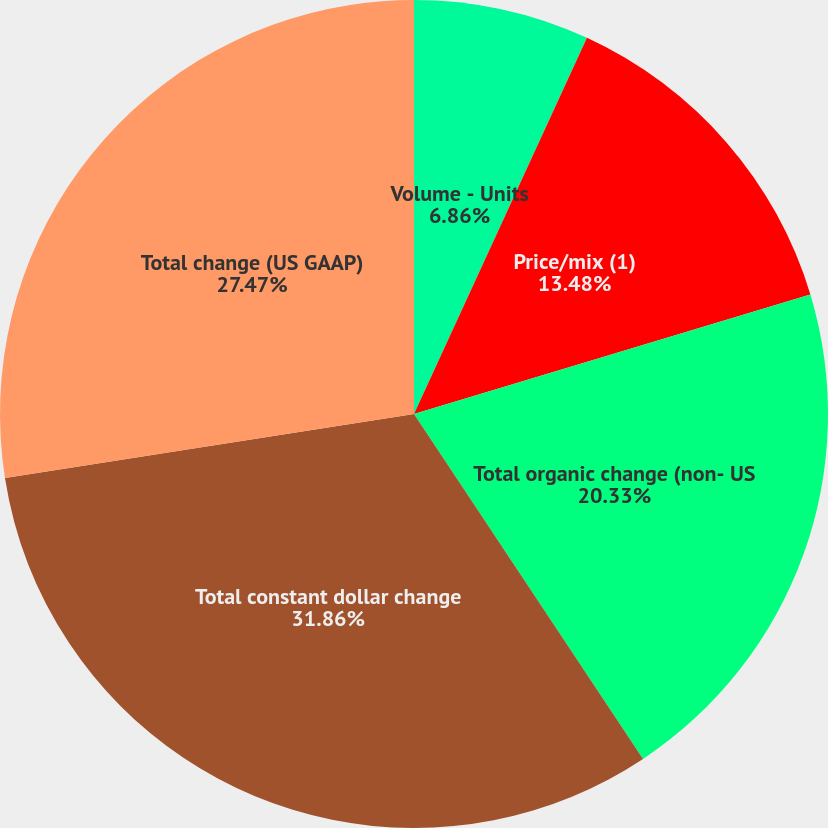Convert chart. <chart><loc_0><loc_0><loc_500><loc_500><pie_chart><fcel>Volume - Units<fcel>Price/mix (1)<fcel>Total organic change (non- US<fcel>Total constant dollar change<fcel>Total change (US GAAP)<nl><fcel>6.86%<fcel>13.48%<fcel>20.33%<fcel>31.86%<fcel>27.47%<nl></chart> 